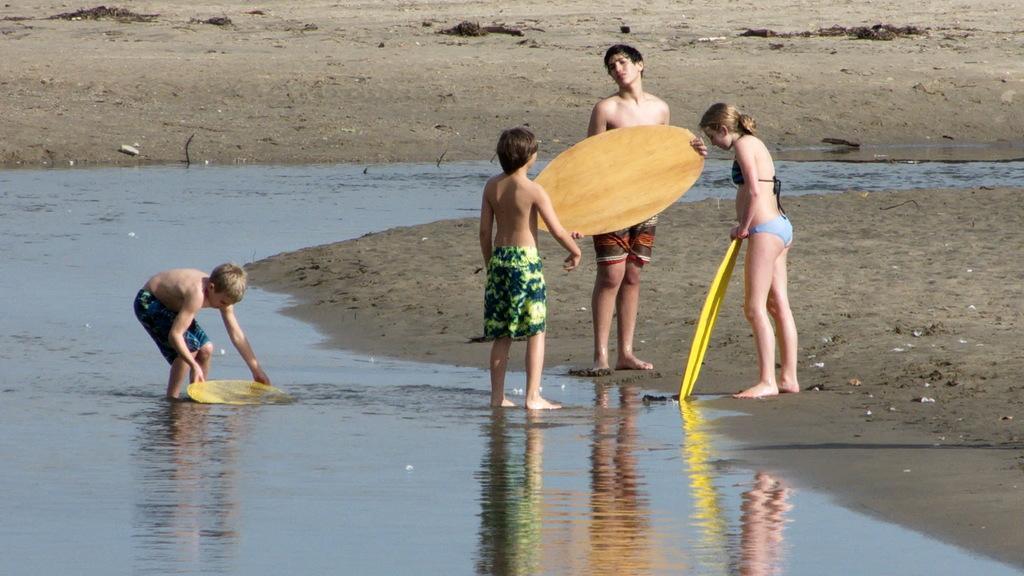Can you describe this image briefly? In this picture we can see some persons in the middle. This is water. Here we can see a man holding a surfing board with his hands. 